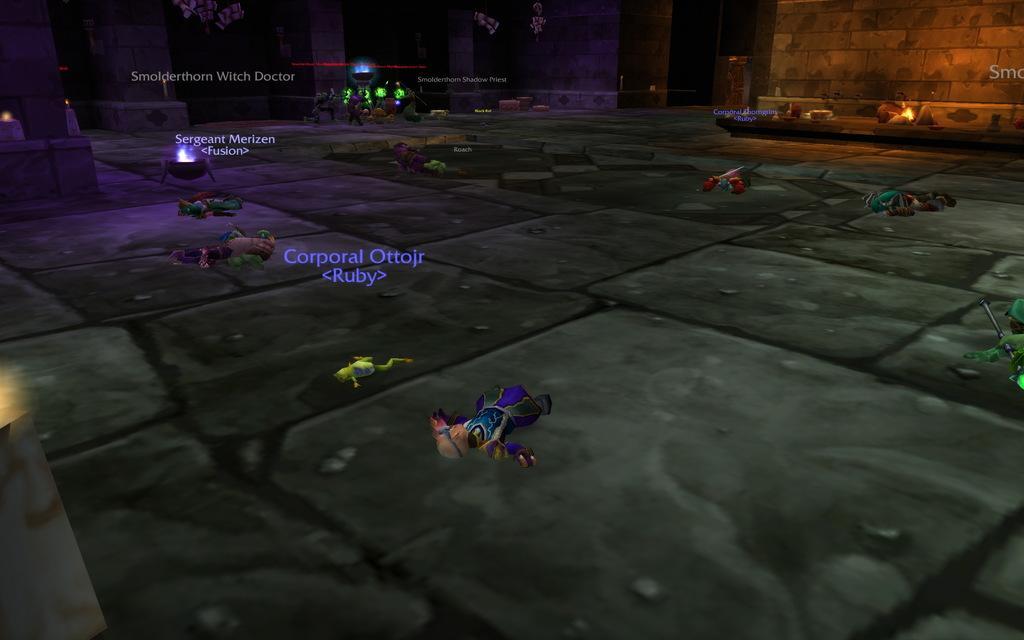Describe this image in one or two sentences. It is an animated image, there are animations of human beings and there is a floor, wall and there are different texts in between the image. 